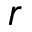Convert formula to latex. <formula><loc_0><loc_0><loc_500><loc_500>r</formula> 